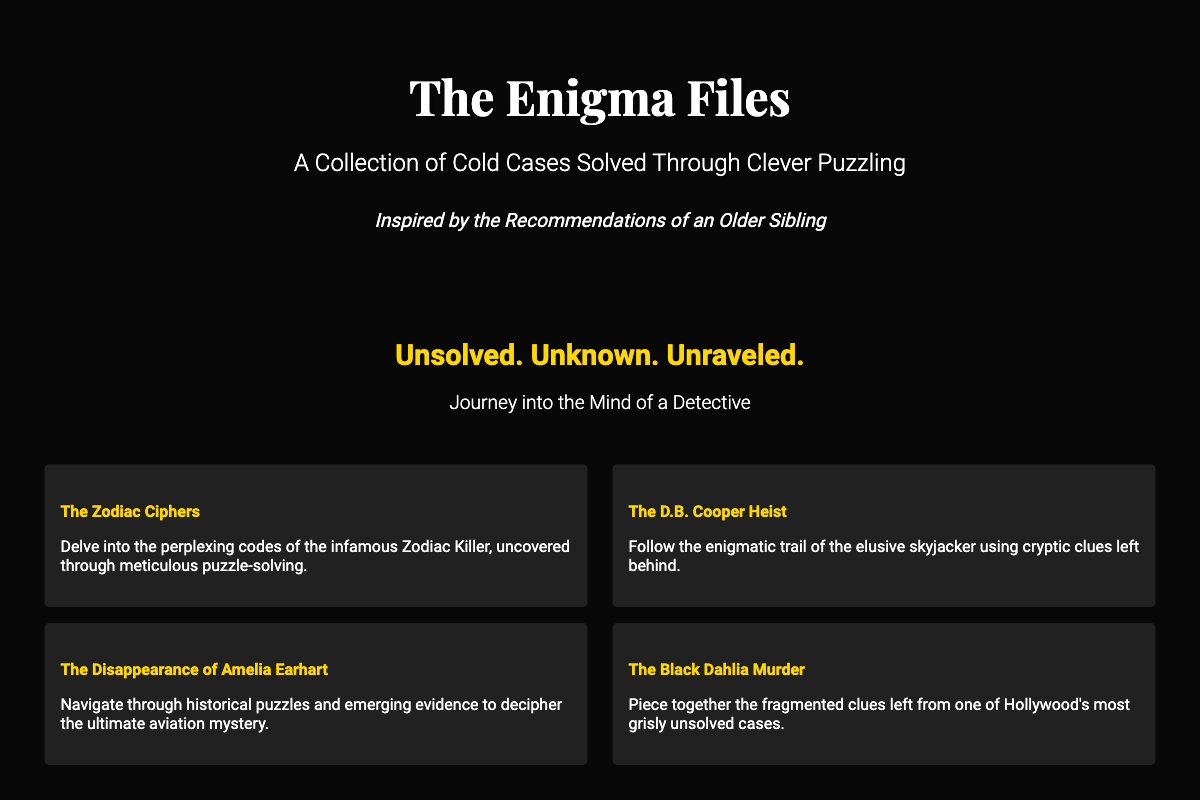What is the title of the book? The title of the book is prominently displayed at the top of the cover.
Answer: The Enigma Files Who is the author inspired by? The author line mentions an inspiration derived from a family relationship.
Answer: An Older Sibling What is the subtitle of the book? The subtitle is underneath the title and describes the book's focus.
Answer: A Collection of Cold Cases Solved Through Clever Puzzling What genre does the book belong to? The footer specifies the genre of the book in a concise manner.
Answer: True Crime / Mystery & Detective How many descriptions of cases are provided on the cover? By counting the sections listed under descriptions, we can determine the number of cases discussed.
Answer: Four What is the main theme highlighted in the text overlay? The text overlay summarizes the overarching concept of the book's narrative.
Answer: Unsolved. Unknown. Unraveled Who is quoted in one of the quotes? The quotes section contains notable figures associated with crime-solving.
Answer: Jessica Fletcher What year was the book published? The footer contains the publication year of the book.
Answer: 2023 What type of press published the book? The footer indicates the name of the press responsible for publishing.
Answer: Whodunit Press 